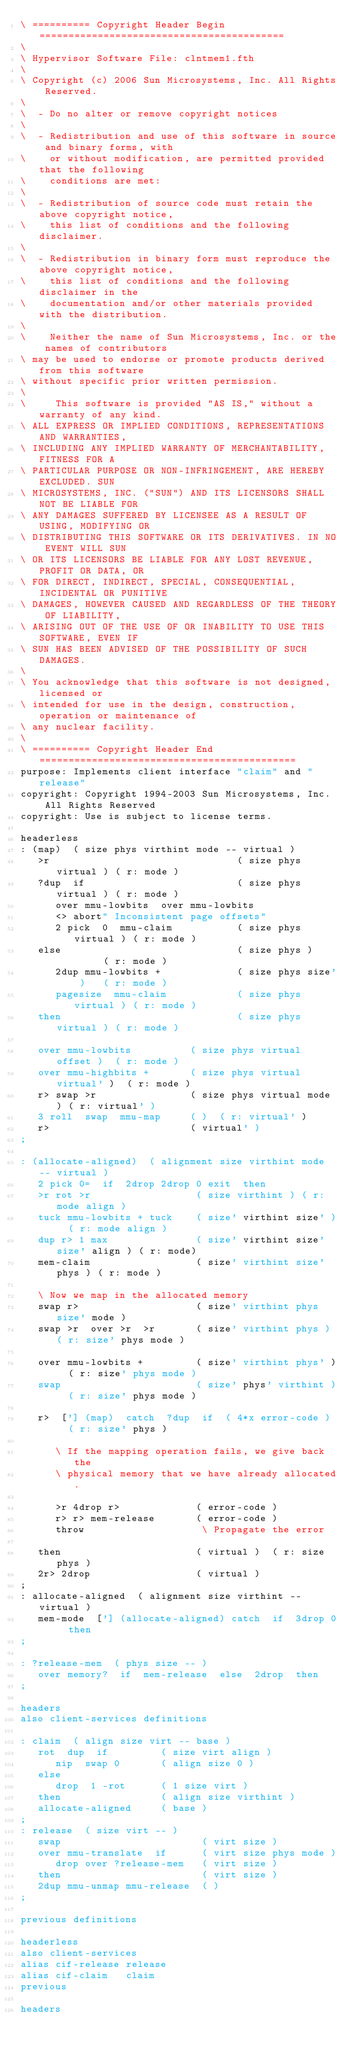<code> <loc_0><loc_0><loc_500><loc_500><_Forth_>\ ========== Copyright Header Begin ==========================================
\ 
\ Hypervisor Software File: clntmem1.fth
\ 
\ Copyright (c) 2006 Sun Microsystems, Inc. All Rights Reserved.
\ 
\  - Do no alter or remove copyright notices
\ 
\  - Redistribution and use of this software in source and binary forms, with 
\    or without modification, are permitted provided that the following 
\    conditions are met: 
\ 
\  - Redistribution of source code must retain the above copyright notice, 
\    this list of conditions and the following disclaimer.
\ 
\  - Redistribution in binary form must reproduce the above copyright notice,
\    this list of conditions and the following disclaimer in the
\    documentation and/or other materials provided with the distribution. 
\ 
\    Neither the name of Sun Microsystems, Inc. or the names of contributors 
\ may be used to endorse or promote products derived from this software 
\ without specific prior written permission. 
\ 
\     This software is provided "AS IS," without a warranty of any kind. 
\ ALL EXPRESS OR IMPLIED CONDITIONS, REPRESENTATIONS AND WARRANTIES, 
\ INCLUDING ANY IMPLIED WARRANTY OF MERCHANTABILITY, FITNESS FOR A 
\ PARTICULAR PURPOSE OR NON-INFRINGEMENT, ARE HEREBY EXCLUDED. SUN 
\ MICROSYSTEMS, INC. ("SUN") AND ITS LICENSORS SHALL NOT BE LIABLE FOR 
\ ANY DAMAGES SUFFERED BY LICENSEE AS A RESULT OF USING, MODIFYING OR 
\ DISTRIBUTING THIS SOFTWARE OR ITS DERIVATIVES. IN NO EVENT WILL SUN 
\ OR ITS LICENSORS BE LIABLE FOR ANY LOST REVENUE, PROFIT OR DATA, OR 
\ FOR DIRECT, INDIRECT, SPECIAL, CONSEQUENTIAL, INCIDENTAL OR PUNITIVE 
\ DAMAGES, HOWEVER CAUSED AND REGARDLESS OF THE THEORY OF LIABILITY, 
\ ARISING OUT OF THE USE OF OR INABILITY TO USE THIS SOFTWARE, EVEN IF 
\ SUN HAS BEEN ADVISED OF THE POSSIBILITY OF SUCH DAMAGES.
\ 
\ You acknowledge that this software is not designed, licensed or
\ intended for use in the design, construction, operation or maintenance of
\ any nuclear facility. 
\ 
\ ========== Copyright Header End ============================================
purpose: Implements client interface "claim" and "release"
copyright: Copyright 1994-2003 Sun Microsystems, Inc.  All Rights Reserved
copyright: Use is subject to license terms.

headerless
: (map)  ( size phys virthint mode -- virtual )
   >r                                ( size phys virtual ) ( r: mode )
   ?dup  if                          ( size phys virtual ) ( r: mode )
      over mmu-lowbits  over mmu-lowbits
      <> abort" Inconsistent page offsets"
      2 pick  0  mmu-claim           ( size phys virtual ) ( r: mode )
   else                              ( size phys )         ( r: mode )
      2dup mmu-lowbits +             ( size phys size' )   ( r: mode )
      pagesize  mmu-claim            ( size phys virtual ) ( r: mode )
   then                              ( size phys virtual ) ( r: mode )

   over mmu-lowbits          ( size phys virtual offset )  ( r: mode )
   over mmu-highbits +       ( size phys virtual virtual' )  ( r: mode )
   r> swap >r                ( size phys virtual mode ) ( r: virtual' )
   3 roll  swap  mmu-map     ( )  ( r: virtual' )
   r>                        ( virtual' )
;

: (allocate-aligned)  ( alignment size virthint mode -- virtual )
   2 pick 0=  if  2drop 2drop 0 exit  then
   >r rot >r                  ( size virthint ) ( r: mode align )
   tuck mmu-lowbits + tuck    ( size' virthint size' )  ( r: mode align )
   dup r> 1 max               ( size' virthint size' size' align ) ( r: mode)
   mem-claim                  ( size' virthint size' phys ) ( r: mode )

   \ Now we map in the allocated memory
   swap r>                    ( size' virthint phys size' mode )
   swap >r  over >r  >r       ( size' virthint phys ) ( r: size' phys mode )

   over mmu-lowbits +         ( size' virthint phys' )  ( r: size' phys mode )
   swap                       ( size' phys' virthint )  ( r: size' phys mode )

   r>  ['] (map)  catch  ?dup  if  ( 4*x error-code )   ( r: size' phys )

      \ If the mapping operation fails, we give back the
      \ physical memory that we have already allocated.

      >r 4drop r>             ( error-code )
      r> r> mem-release       ( error-code )
      throw                    \ Propagate the error

   then                       ( virtual )  ( r: size phys )
   2r> 2drop                  ( virtual )
;
: allocate-aligned  ( alignment size virthint -- virtual )
   mem-mode  ['] (allocate-aligned) catch  if  3drop 0  then
;

: ?release-mem  ( phys size -- )
   over memory?  if  mem-release  else  2drop  then
;

headers
also client-services definitions

: claim  ( align size virt -- base )
   rot  dup  if         ( size virt align )
      nip  swap 0       ( align size 0 )
   else
      drop  1 -rot      ( 1 size virt )
   then                 ( align size virthint )
   allocate-aligned     ( base )
;
: release  ( size virt -- )
   swap                        ( virt size )
   over mmu-translate  if      ( virt size phys mode )
      drop over ?release-mem   ( virt size )
   then                        ( virt size )
   2dup mmu-unmap mmu-release  ( )
;

previous definitions

headerless
also client-services
alias cif-release release
alias cif-claim   claim
previous

headers
</code> 